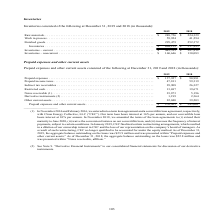According to First Solar's financial document, What is the interest rate of the term loan? Our term loan bears interest at 16% per annum. The document states: "ively, with Clean Energy Collective, LLC (“CEC”). Our term loan bears interest at 16% per annum, and our convertible loan bears interest at 10% per an..." Also, What amendment was made to the convertible loan agreement in 2018? waive the conversion features on our convertible loan. The document states: "s to (i) extend their maturity to June 2020, (ii) waive the conversion features on our convertible loan, and (iii) increase the frequency of interest ..." Also, Why is CEC no longer qualified to be accounted under the equity method in 2019? CEC finalized certain restructuring arrangements, which resulted in a dilution of our ownership interest in CEC and the loss of our representation on the company’s board of managers. The document states: ", subject to certain conditions. In January 2019, CEC finalized certain restructuring arrangements, which resulted in a dilution of our ownership inte..." Also, can you calculate: How much was the increase in prepaid expenses from 2018 to 2019? Based on the calculation: 137,927-90,981 , the result is 46946 (in thousands). This is based on the information: "2019 2018 Prepaid expenses . $ 137,927 $ 90,981 Prepaid income taxes . 47,811 59,319 Indirect tax receivables . 29,908 26,327 Restricted c 2019 2018 Prepaid expenses . $ 137,927 $ 90,981 Prepaid incom..." The key data points involved are: 137,927, 90,981. Also, can you calculate: What is the difference between notes receivables from 2018 to 2019? Based on the calculation: 23,873 - 5,196 , the result is 18677 (in thousands). This is based on the information: "sh . 13,697 19,671 Notes receivable (1). . 23,873 5,196 Derivative instruments (2) . 1,199 2,364 Other current assets . 22,040 39,203 Prepaid expenses and cted cash . 13,697 19,671 Notes receivable (1..." The key data points involved are: 23,873, 5,196. Also, can you calculate: What is the percentage increase in total prepaid expenses and other current assets from 2018 to 2019? To answer this question, I need to perform calculations using the financial data. The calculation is: (276,455- 243,061)/243,061 , which equals 13.74 (percentage). This is based on the information: "203 Prepaid expenses and other current assets . $ 276,455 $ 243,061 d expenses and other current assets . $ 276,455 $ 243,061..." The key data points involved are: 243,061, 276,455. 